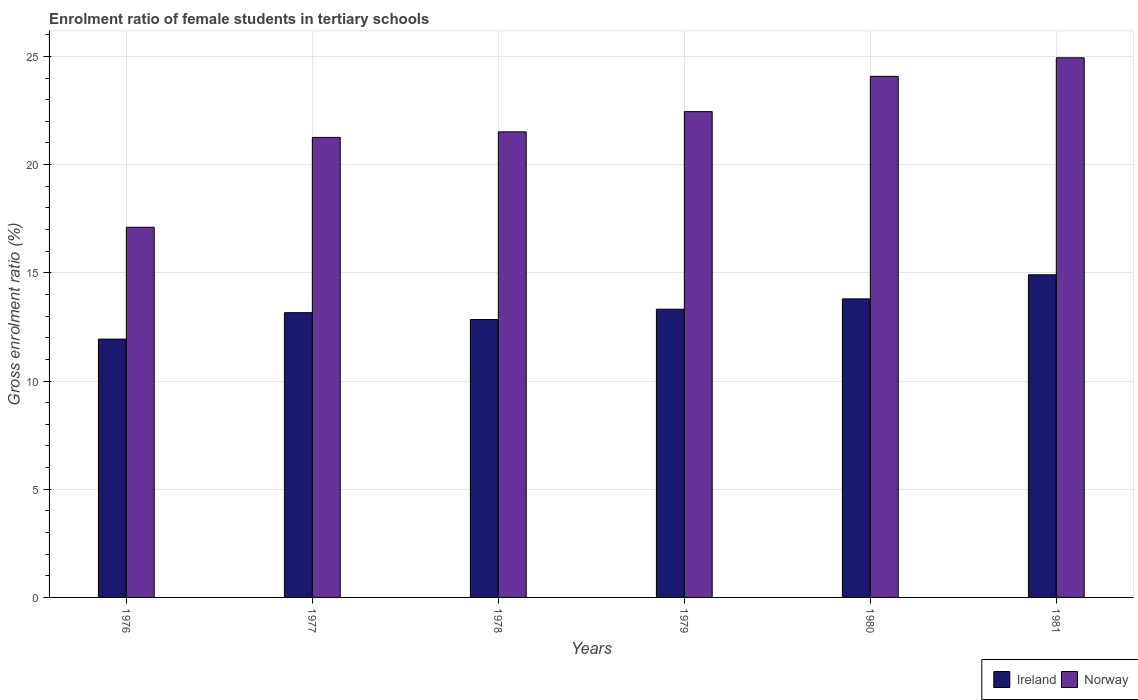How many different coloured bars are there?
Your answer should be very brief. 2. How many groups of bars are there?
Your answer should be very brief. 6. Are the number of bars per tick equal to the number of legend labels?
Offer a very short reply. Yes. What is the label of the 6th group of bars from the left?
Ensure brevity in your answer.  1981. In how many cases, is the number of bars for a given year not equal to the number of legend labels?
Offer a very short reply. 0. What is the enrolment ratio of female students in tertiary schools in Ireland in 1978?
Offer a terse response. 12.84. Across all years, what is the maximum enrolment ratio of female students in tertiary schools in Norway?
Offer a very short reply. 24.94. Across all years, what is the minimum enrolment ratio of female students in tertiary schools in Ireland?
Provide a short and direct response. 11.94. In which year was the enrolment ratio of female students in tertiary schools in Norway maximum?
Offer a very short reply. 1981. In which year was the enrolment ratio of female students in tertiary schools in Ireland minimum?
Offer a very short reply. 1976. What is the total enrolment ratio of female students in tertiary schools in Ireland in the graph?
Ensure brevity in your answer.  79.96. What is the difference between the enrolment ratio of female students in tertiary schools in Norway in 1976 and that in 1977?
Ensure brevity in your answer.  -4.15. What is the difference between the enrolment ratio of female students in tertiary schools in Ireland in 1981 and the enrolment ratio of female students in tertiary schools in Norway in 1979?
Ensure brevity in your answer.  -7.54. What is the average enrolment ratio of female students in tertiary schools in Ireland per year?
Make the answer very short. 13.33. In the year 1981, what is the difference between the enrolment ratio of female students in tertiary schools in Norway and enrolment ratio of female students in tertiary schools in Ireland?
Provide a succinct answer. 10.03. In how many years, is the enrolment ratio of female students in tertiary schools in Ireland greater than 16 %?
Ensure brevity in your answer.  0. What is the ratio of the enrolment ratio of female students in tertiary schools in Ireland in 1976 to that in 1978?
Ensure brevity in your answer.  0.93. Is the enrolment ratio of female students in tertiary schools in Norway in 1978 less than that in 1980?
Provide a short and direct response. Yes. Is the difference between the enrolment ratio of female students in tertiary schools in Norway in 1976 and 1980 greater than the difference between the enrolment ratio of female students in tertiary schools in Ireland in 1976 and 1980?
Ensure brevity in your answer.  No. What is the difference between the highest and the second highest enrolment ratio of female students in tertiary schools in Ireland?
Offer a terse response. 1.11. What is the difference between the highest and the lowest enrolment ratio of female students in tertiary schools in Ireland?
Your answer should be very brief. 2.97. In how many years, is the enrolment ratio of female students in tertiary schools in Ireland greater than the average enrolment ratio of female students in tertiary schools in Ireland taken over all years?
Your response must be concise. 2. What does the 1st bar from the right in 1980 represents?
Ensure brevity in your answer.  Norway. How many bars are there?
Keep it short and to the point. 12. How many years are there in the graph?
Make the answer very short. 6. Does the graph contain any zero values?
Your answer should be very brief. No. Does the graph contain grids?
Your response must be concise. Yes. How are the legend labels stacked?
Make the answer very short. Horizontal. What is the title of the graph?
Your answer should be very brief. Enrolment ratio of female students in tertiary schools. What is the label or title of the Y-axis?
Offer a very short reply. Gross enrolment ratio (%). What is the Gross enrolment ratio (%) in Ireland in 1976?
Give a very brief answer. 11.94. What is the Gross enrolment ratio (%) in Norway in 1976?
Your response must be concise. 17.1. What is the Gross enrolment ratio (%) of Ireland in 1977?
Ensure brevity in your answer.  13.16. What is the Gross enrolment ratio (%) in Norway in 1977?
Your answer should be compact. 21.26. What is the Gross enrolment ratio (%) in Ireland in 1978?
Your answer should be very brief. 12.84. What is the Gross enrolment ratio (%) in Norway in 1978?
Ensure brevity in your answer.  21.51. What is the Gross enrolment ratio (%) in Ireland in 1979?
Provide a succinct answer. 13.32. What is the Gross enrolment ratio (%) of Norway in 1979?
Your answer should be compact. 22.45. What is the Gross enrolment ratio (%) of Ireland in 1980?
Offer a very short reply. 13.8. What is the Gross enrolment ratio (%) in Norway in 1980?
Keep it short and to the point. 24.08. What is the Gross enrolment ratio (%) in Ireland in 1981?
Ensure brevity in your answer.  14.91. What is the Gross enrolment ratio (%) in Norway in 1981?
Your answer should be compact. 24.94. Across all years, what is the maximum Gross enrolment ratio (%) of Ireland?
Offer a very short reply. 14.91. Across all years, what is the maximum Gross enrolment ratio (%) of Norway?
Ensure brevity in your answer.  24.94. Across all years, what is the minimum Gross enrolment ratio (%) in Ireland?
Offer a terse response. 11.94. Across all years, what is the minimum Gross enrolment ratio (%) in Norway?
Your answer should be very brief. 17.1. What is the total Gross enrolment ratio (%) in Ireland in the graph?
Ensure brevity in your answer.  79.96. What is the total Gross enrolment ratio (%) in Norway in the graph?
Keep it short and to the point. 131.34. What is the difference between the Gross enrolment ratio (%) in Ireland in 1976 and that in 1977?
Ensure brevity in your answer.  -1.22. What is the difference between the Gross enrolment ratio (%) of Norway in 1976 and that in 1977?
Provide a short and direct response. -4.15. What is the difference between the Gross enrolment ratio (%) in Ireland in 1976 and that in 1978?
Keep it short and to the point. -0.9. What is the difference between the Gross enrolment ratio (%) in Norway in 1976 and that in 1978?
Provide a short and direct response. -4.41. What is the difference between the Gross enrolment ratio (%) of Ireland in 1976 and that in 1979?
Offer a terse response. -1.38. What is the difference between the Gross enrolment ratio (%) in Norway in 1976 and that in 1979?
Offer a very short reply. -5.34. What is the difference between the Gross enrolment ratio (%) of Ireland in 1976 and that in 1980?
Your response must be concise. -1.86. What is the difference between the Gross enrolment ratio (%) of Norway in 1976 and that in 1980?
Give a very brief answer. -6.97. What is the difference between the Gross enrolment ratio (%) in Ireland in 1976 and that in 1981?
Provide a short and direct response. -2.97. What is the difference between the Gross enrolment ratio (%) in Norway in 1976 and that in 1981?
Make the answer very short. -7.83. What is the difference between the Gross enrolment ratio (%) in Ireland in 1977 and that in 1978?
Provide a succinct answer. 0.32. What is the difference between the Gross enrolment ratio (%) of Norway in 1977 and that in 1978?
Offer a terse response. -0.26. What is the difference between the Gross enrolment ratio (%) of Ireland in 1977 and that in 1979?
Give a very brief answer. -0.16. What is the difference between the Gross enrolment ratio (%) of Norway in 1977 and that in 1979?
Provide a succinct answer. -1.19. What is the difference between the Gross enrolment ratio (%) of Ireland in 1977 and that in 1980?
Give a very brief answer. -0.64. What is the difference between the Gross enrolment ratio (%) in Norway in 1977 and that in 1980?
Ensure brevity in your answer.  -2.82. What is the difference between the Gross enrolment ratio (%) in Ireland in 1977 and that in 1981?
Offer a very short reply. -1.75. What is the difference between the Gross enrolment ratio (%) of Norway in 1977 and that in 1981?
Provide a short and direct response. -3.68. What is the difference between the Gross enrolment ratio (%) of Ireland in 1978 and that in 1979?
Your answer should be very brief. -0.48. What is the difference between the Gross enrolment ratio (%) of Norway in 1978 and that in 1979?
Make the answer very short. -0.93. What is the difference between the Gross enrolment ratio (%) of Ireland in 1978 and that in 1980?
Provide a succinct answer. -0.95. What is the difference between the Gross enrolment ratio (%) in Norway in 1978 and that in 1980?
Your answer should be very brief. -2.57. What is the difference between the Gross enrolment ratio (%) in Ireland in 1978 and that in 1981?
Your answer should be compact. -2.07. What is the difference between the Gross enrolment ratio (%) of Norway in 1978 and that in 1981?
Provide a short and direct response. -3.42. What is the difference between the Gross enrolment ratio (%) of Ireland in 1979 and that in 1980?
Provide a short and direct response. -0.48. What is the difference between the Gross enrolment ratio (%) of Norway in 1979 and that in 1980?
Offer a very short reply. -1.63. What is the difference between the Gross enrolment ratio (%) in Ireland in 1979 and that in 1981?
Keep it short and to the point. -1.59. What is the difference between the Gross enrolment ratio (%) in Norway in 1979 and that in 1981?
Give a very brief answer. -2.49. What is the difference between the Gross enrolment ratio (%) of Ireland in 1980 and that in 1981?
Your response must be concise. -1.11. What is the difference between the Gross enrolment ratio (%) in Norway in 1980 and that in 1981?
Your answer should be very brief. -0.86. What is the difference between the Gross enrolment ratio (%) of Ireland in 1976 and the Gross enrolment ratio (%) of Norway in 1977?
Offer a terse response. -9.32. What is the difference between the Gross enrolment ratio (%) of Ireland in 1976 and the Gross enrolment ratio (%) of Norway in 1978?
Offer a terse response. -9.58. What is the difference between the Gross enrolment ratio (%) in Ireland in 1976 and the Gross enrolment ratio (%) in Norway in 1979?
Keep it short and to the point. -10.51. What is the difference between the Gross enrolment ratio (%) in Ireland in 1976 and the Gross enrolment ratio (%) in Norway in 1980?
Give a very brief answer. -12.14. What is the difference between the Gross enrolment ratio (%) of Ireland in 1976 and the Gross enrolment ratio (%) of Norway in 1981?
Your answer should be very brief. -13. What is the difference between the Gross enrolment ratio (%) in Ireland in 1977 and the Gross enrolment ratio (%) in Norway in 1978?
Provide a short and direct response. -8.36. What is the difference between the Gross enrolment ratio (%) in Ireland in 1977 and the Gross enrolment ratio (%) in Norway in 1979?
Give a very brief answer. -9.29. What is the difference between the Gross enrolment ratio (%) of Ireland in 1977 and the Gross enrolment ratio (%) of Norway in 1980?
Provide a short and direct response. -10.92. What is the difference between the Gross enrolment ratio (%) of Ireland in 1977 and the Gross enrolment ratio (%) of Norway in 1981?
Ensure brevity in your answer.  -11.78. What is the difference between the Gross enrolment ratio (%) in Ireland in 1978 and the Gross enrolment ratio (%) in Norway in 1979?
Provide a short and direct response. -9.61. What is the difference between the Gross enrolment ratio (%) of Ireland in 1978 and the Gross enrolment ratio (%) of Norway in 1980?
Offer a terse response. -11.24. What is the difference between the Gross enrolment ratio (%) of Ireland in 1978 and the Gross enrolment ratio (%) of Norway in 1981?
Provide a succinct answer. -12.09. What is the difference between the Gross enrolment ratio (%) in Ireland in 1979 and the Gross enrolment ratio (%) in Norway in 1980?
Your answer should be compact. -10.76. What is the difference between the Gross enrolment ratio (%) in Ireland in 1979 and the Gross enrolment ratio (%) in Norway in 1981?
Keep it short and to the point. -11.62. What is the difference between the Gross enrolment ratio (%) in Ireland in 1980 and the Gross enrolment ratio (%) in Norway in 1981?
Provide a succinct answer. -11.14. What is the average Gross enrolment ratio (%) in Ireland per year?
Ensure brevity in your answer.  13.33. What is the average Gross enrolment ratio (%) in Norway per year?
Ensure brevity in your answer.  21.89. In the year 1976, what is the difference between the Gross enrolment ratio (%) in Ireland and Gross enrolment ratio (%) in Norway?
Keep it short and to the point. -5.17. In the year 1977, what is the difference between the Gross enrolment ratio (%) in Ireland and Gross enrolment ratio (%) in Norway?
Your answer should be compact. -8.1. In the year 1978, what is the difference between the Gross enrolment ratio (%) of Ireland and Gross enrolment ratio (%) of Norway?
Your answer should be compact. -8.67. In the year 1979, what is the difference between the Gross enrolment ratio (%) of Ireland and Gross enrolment ratio (%) of Norway?
Offer a terse response. -9.13. In the year 1980, what is the difference between the Gross enrolment ratio (%) of Ireland and Gross enrolment ratio (%) of Norway?
Keep it short and to the point. -10.28. In the year 1981, what is the difference between the Gross enrolment ratio (%) of Ireland and Gross enrolment ratio (%) of Norway?
Keep it short and to the point. -10.03. What is the ratio of the Gross enrolment ratio (%) of Ireland in 1976 to that in 1977?
Offer a very short reply. 0.91. What is the ratio of the Gross enrolment ratio (%) in Norway in 1976 to that in 1977?
Provide a short and direct response. 0.8. What is the ratio of the Gross enrolment ratio (%) in Ireland in 1976 to that in 1978?
Provide a short and direct response. 0.93. What is the ratio of the Gross enrolment ratio (%) in Norway in 1976 to that in 1978?
Keep it short and to the point. 0.8. What is the ratio of the Gross enrolment ratio (%) of Ireland in 1976 to that in 1979?
Provide a succinct answer. 0.9. What is the ratio of the Gross enrolment ratio (%) of Norway in 1976 to that in 1979?
Offer a terse response. 0.76. What is the ratio of the Gross enrolment ratio (%) of Ireland in 1976 to that in 1980?
Your answer should be compact. 0.87. What is the ratio of the Gross enrolment ratio (%) of Norway in 1976 to that in 1980?
Offer a very short reply. 0.71. What is the ratio of the Gross enrolment ratio (%) in Ireland in 1976 to that in 1981?
Ensure brevity in your answer.  0.8. What is the ratio of the Gross enrolment ratio (%) in Norway in 1976 to that in 1981?
Your answer should be compact. 0.69. What is the ratio of the Gross enrolment ratio (%) in Ireland in 1977 to that in 1978?
Make the answer very short. 1.02. What is the ratio of the Gross enrolment ratio (%) of Norway in 1977 to that in 1978?
Offer a very short reply. 0.99. What is the ratio of the Gross enrolment ratio (%) of Ireland in 1977 to that in 1979?
Give a very brief answer. 0.99. What is the ratio of the Gross enrolment ratio (%) in Norway in 1977 to that in 1979?
Your response must be concise. 0.95. What is the ratio of the Gross enrolment ratio (%) of Ireland in 1977 to that in 1980?
Give a very brief answer. 0.95. What is the ratio of the Gross enrolment ratio (%) of Norway in 1977 to that in 1980?
Your answer should be compact. 0.88. What is the ratio of the Gross enrolment ratio (%) of Ireland in 1977 to that in 1981?
Offer a terse response. 0.88. What is the ratio of the Gross enrolment ratio (%) of Norway in 1977 to that in 1981?
Make the answer very short. 0.85. What is the ratio of the Gross enrolment ratio (%) of Ireland in 1978 to that in 1979?
Make the answer very short. 0.96. What is the ratio of the Gross enrolment ratio (%) in Norway in 1978 to that in 1979?
Make the answer very short. 0.96. What is the ratio of the Gross enrolment ratio (%) in Ireland in 1978 to that in 1980?
Ensure brevity in your answer.  0.93. What is the ratio of the Gross enrolment ratio (%) of Norway in 1978 to that in 1980?
Your response must be concise. 0.89. What is the ratio of the Gross enrolment ratio (%) of Ireland in 1978 to that in 1981?
Offer a very short reply. 0.86. What is the ratio of the Gross enrolment ratio (%) of Norway in 1978 to that in 1981?
Ensure brevity in your answer.  0.86. What is the ratio of the Gross enrolment ratio (%) of Ireland in 1979 to that in 1980?
Offer a very short reply. 0.97. What is the ratio of the Gross enrolment ratio (%) in Norway in 1979 to that in 1980?
Offer a very short reply. 0.93. What is the ratio of the Gross enrolment ratio (%) in Ireland in 1979 to that in 1981?
Provide a short and direct response. 0.89. What is the ratio of the Gross enrolment ratio (%) of Norway in 1979 to that in 1981?
Your answer should be compact. 0.9. What is the ratio of the Gross enrolment ratio (%) of Ireland in 1980 to that in 1981?
Keep it short and to the point. 0.93. What is the ratio of the Gross enrolment ratio (%) of Norway in 1980 to that in 1981?
Give a very brief answer. 0.97. What is the difference between the highest and the second highest Gross enrolment ratio (%) of Ireland?
Offer a very short reply. 1.11. What is the difference between the highest and the second highest Gross enrolment ratio (%) of Norway?
Your answer should be compact. 0.86. What is the difference between the highest and the lowest Gross enrolment ratio (%) in Ireland?
Provide a succinct answer. 2.97. What is the difference between the highest and the lowest Gross enrolment ratio (%) of Norway?
Provide a succinct answer. 7.83. 